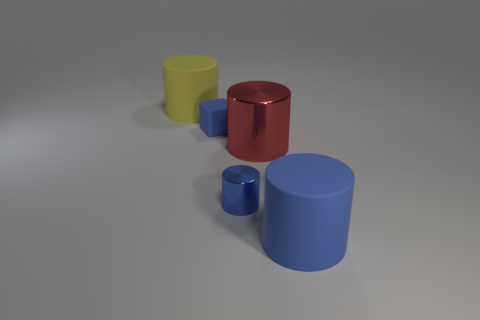Add 1 large cylinders. How many objects exist? 6 Subtract all cylinders. How many objects are left? 1 Subtract 0 brown blocks. How many objects are left? 5 Subtract all tiny blue blocks. Subtract all large red matte cubes. How many objects are left? 4 Add 1 large blue rubber cylinders. How many large blue rubber cylinders are left? 2 Add 5 small metal spheres. How many small metal spheres exist? 5 